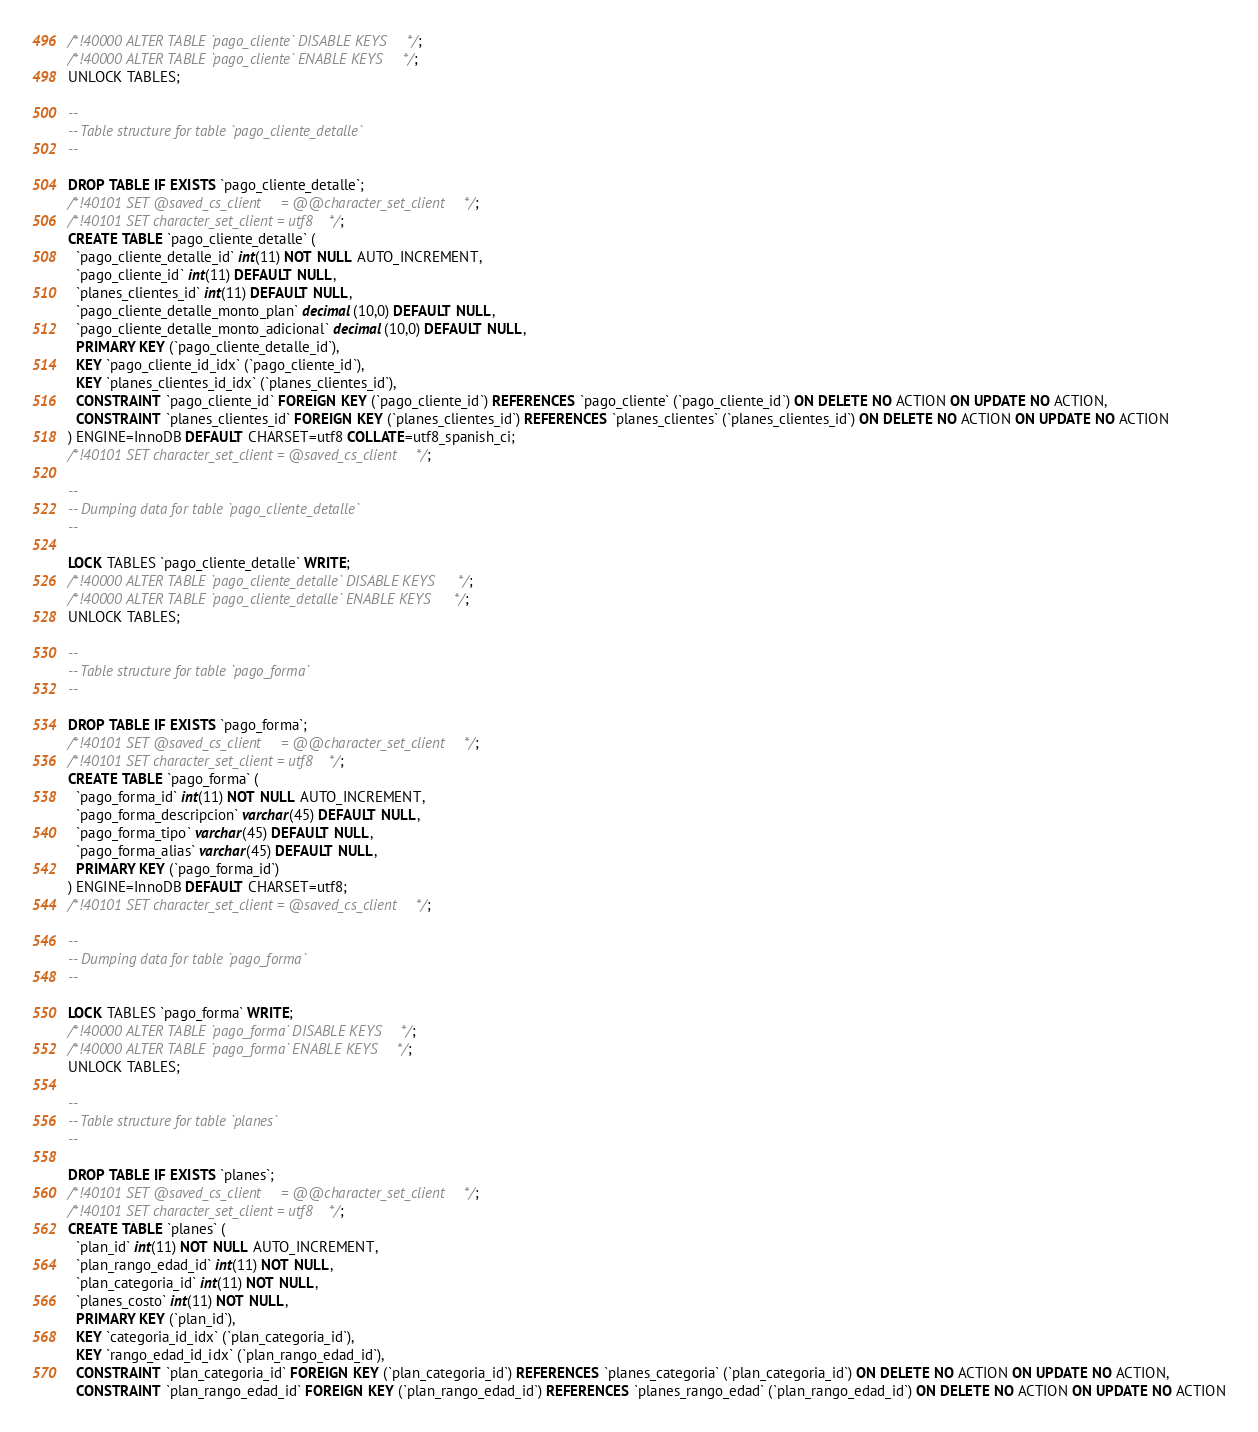<code> <loc_0><loc_0><loc_500><loc_500><_SQL_>/*!40000 ALTER TABLE `pago_cliente` DISABLE KEYS */;
/*!40000 ALTER TABLE `pago_cliente` ENABLE KEYS */;
UNLOCK TABLES;

--
-- Table structure for table `pago_cliente_detalle`
--

DROP TABLE IF EXISTS `pago_cliente_detalle`;
/*!40101 SET @saved_cs_client     = @@character_set_client */;
/*!40101 SET character_set_client = utf8 */;
CREATE TABLE `pago_cliente_detalle` (
  `pago_cliente_detalle_id` int(11) NOT NULL AUTO_INCREMENT,
  `pago_cliente_id` int(11) DEFAULT NULL,
  `planes_clientes_id` int(11) DEFAULT NULL,
  `pago_cliente_detalle_monto_plan` decimal(10,0) DEFAULT NULL,
  `pago_cliente_detalle_monto_adicional` decimal(10,0) DEFAULT NULL,
  PRIMARY KEY (`pago_cliente_detalle_id`),
  KEY `pago_cliente_id_idx` (`pago_cliente_id`),
  KEY `planes_clientes_id_idx` (`planes_clientes_id`),
  CONSTRAINT `pago_cliente_id` FOREIGN KEY (`pago_cliente_id`) REFERENCES `pago_cliente` (`pago_cliente_id`) ON DELETE NO ACTION ON UPDATE NO ACTION,
  CONSTRAINT `planes_clientes_id` FOREIGN KEY (`planes_clientes_id`) REFERENCES `planes_clientes` (`planes_clientes_id`) ON DELETE NO ACTION ON UPDATE NO ACTION
) ENGINE=InnoDB DEFAULT CHARSET=utf8 COLLATE=utf8_spanish_ci;
/*!40101 SET character_set_client = @saved_cs_client */;

--
-- Dumping data for table `pago_cliente_detalle`
--

LOCK TABLES `pago_cliente_detalle` WRITE;
/*!40000 ALTER TABLE `pago_cliente_detalle` DISABLE KEYS */;
/*!40000 ALTER TABLE `pago_cliente_detalle` ENABLE KEYS */;
UNLOCK TABLES;

--
-- Table structure for table `pago_forma`
--

DROP TABLE IF EXISTS `pago_forma`;
/*!40101 SET @saved_cs_client     = @@character_set_client */;
/*!40101 SET character_set_client = utf8 */;
CREATE TABLE `pago_forma` (
  `pago_forma_id` int(11) NOT NULL AUTO_INCREMENT,
  `pago_forma_descripcion` varchar(45) DEFAULT NULL,
  `pago_forma_tipo` varchar(45) DEFAULT NULL,
  `pago_forma_alias` varchar(45) DEFAULT NULL,
  PRIMARY KEY (`pago_forma_id`)
) ENGINE=InnoDB DEFAULT CHARSET=utf8;
/*!40101 SET character_set_client = @saved_cs_client */;

--
-- Dumping data for table `pago_forma`
--

LOCK TABLES `pago_forma` WRITE;
/*!40000 ALTER TABLE `pago_forma` DISABLE KEYS */;
/*!40000 ALTER TABLE `pago_forma` ENABLE KEYS */;
UNLOCK TABLES;

--
-- Table structure for table `planes`
--

DROP TABLE IF EXISTS `planes`;
/*!40101 SET @saved_cs_client     = @@character_set_client */;
/*!40101 SET character_set_client = utf8 */;
CREATE TABLE `planes` (
  `plan_id` int(11) NOT NULL AUTO_INCREMENT,
  `plan_rango_edad_id` int(11) NOT NULL,
  `plan_categoria_id` int(11) NOT NULL,
  `planes_costo` int(11) NOT NULL,
  PRIMARY KEY (`plan_id`),
  KEY `categoria_id_idx` (`plan_categoria_id`),
  KEY `rango_edad_id_idx` (`plan_rango_edad_id`),
  CONSTRAINT `plan_categoria_id` FOREIGN KEY (`plan_categoria_id`) REFERENCES `planes_categoria` (`plan_categoria_id`) ON DELETE NO ACTION ON UPDATE NO ACTION,
  CONSTRAINT `plan_rango_edad_id` FOREIGN KEY (`plan_rango_edad_id`) REFERENCES `planes_rango_edad` (`plan_rango_edad_id`) ON DELETE NO ACTION ON UPDATE NO ACTION</code> 